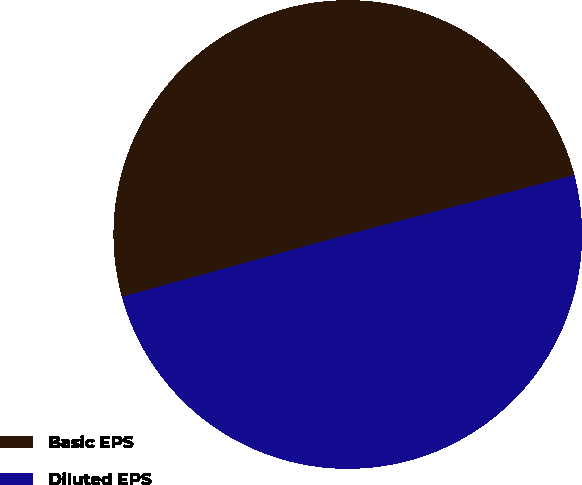<chart> <loc_0><loc_0><loc_500><loc_500><pie_chart><fcel>Basic EPS<fcel>Diluted EPS<nl><fcel>50.21%<fcel>49.79%<nl></chart> 